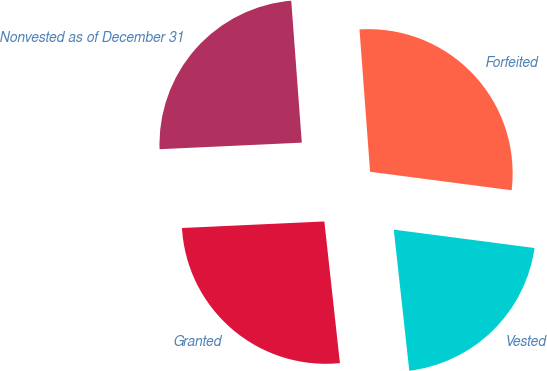Convert chart. <chart><loc_0><loc_0><loc_500><loc_500><pie_chart><fcel>Nonvested as of December 31<fcel>Granted<fcel>Vested<fcel>Forfeited<nl><fcel>24.55%<fcel>26.01%<fcel>21.19%<fcel>28.25%<nl></chart> 